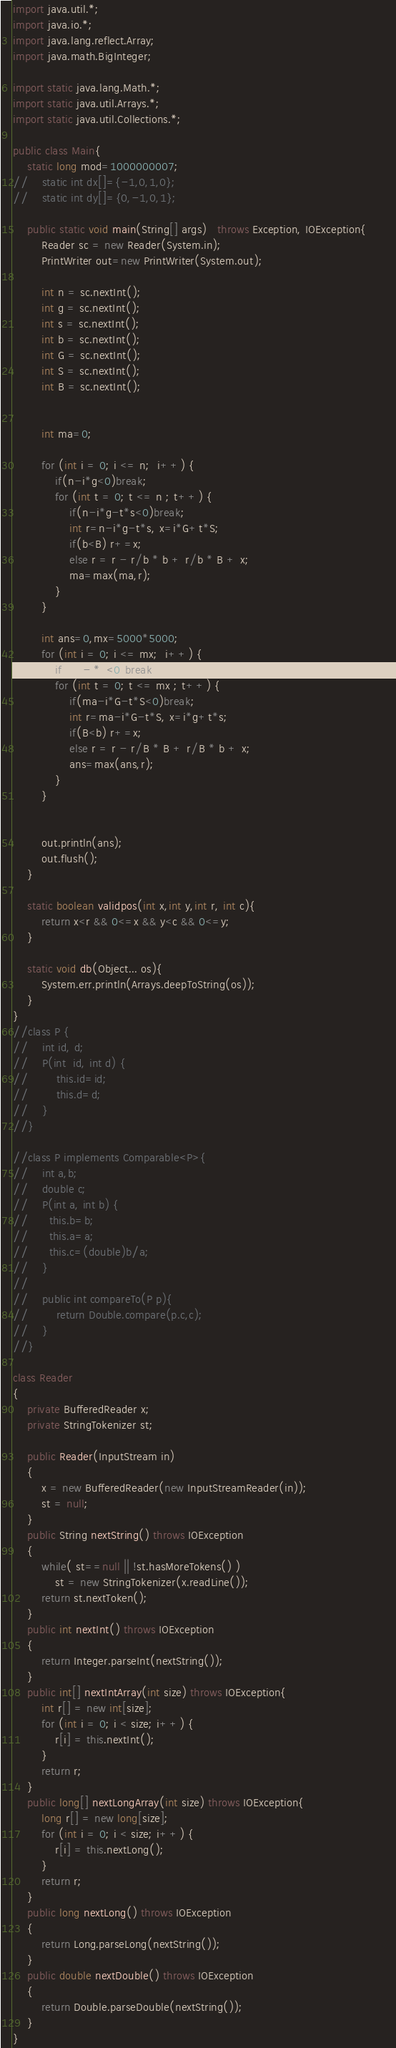<code> <loc_0><loc_0><loc_500><loc_500><_Java_>import java.util.*;
import java.io.*;
import java.lang.reflect.Array;
import java.math.BigInteger;

import static java.lang.Math.*;
import static java.util.Arrays.*;
import static java.util.Collections.*;
 
public class Main{
    static long mod=1000000007;
//    static int dx[]={-1,0,1,0};
//    static int dy[]={0,-1,0,1};

    public static void main(String[] args)   throws Exception, IOException{        
        Reader sc = new Reader(System.in);
        PrintWriter out=new PrintWriter(System.out);

        int n = sc.nextInt();
        int g = sc.nextInt();
        int s = sc.nextInt();
        int b = sc.nextInt();
        int G = sc.nextInt();
        int S = sc.nextInt();
        int B = sc.nextInt();

        
        int ma=0;
        
        for (int i = 0; i <= n;  i++) {
        	if(n-i*g<0)break;
			for (int t = 0; t <= n ; t++) {
	        	if(n-i*g-t*s<0)break;
				int r=n-i*g-t*s, x=i*G+t*S;
				if(b<B) r+=x;
				else r = r - r/b * b + r/b * B + x;
				ma=max(ma,r);
			}
		}
        
        int ans=0,mx=5000*5000;
        for (int i = 0; i <= mx;  i++) {
        	if(ma-i*G<0)break;
			for (int t = 0; t <= mx ; t++) {
	        	if(ma-i*G-t*S<0)break;
				int r=ma-i*G-t*S, x=i*g+t*s;
				if(B<b) r+=x;
				else r = r - r/B * B + r/B * b + x;
				ans=max(ans,r);
			}
		}


        out.println(ans);
        out.flush();
    }

    static boolean validpos(int x,int y,int r, int c){
        return x<r && 0<=x && y<c && 0<=y;
    }

    static void db(Object... os){
        System.err.println(Arrays.deepToString(os));
    }
}
//class P {
//    int id, d;
//    P(int  id, int d) {
//        this.id=id;
//        this.d=d;
//    }
//}

//class P implements Comparable<P>{
//    int a,b;
//    double c;
//    P(int a, int b) {
//    	this.b=b;
//    	this.a=a;
//    	this.c=(double)b/a;
//    }
//
//    public int compareTo(P p){
//        return Double.compare(p.c,c);
//    }
//}

class Reader
{ 
    private BufferedReader x;
    private StringTokenizer st;
    
    public Reader(InputStream in)
    {
        x = new BufferedReader(new InputStreamReader(in));
        st = null;
    }
    public String nextString() throws IOException
    {
        while( st==null || !st.hasMoreTokens() )
            st = new StringTokenizer(x.readLine());
        return st.nextToken();
    }
    public int nextInt() throws IOException
    {
        return Integer.parseInt(nextString());
    }
    public int[] nextIntArray(int size) throws IOException{
        int r[] = new int[size];
        for (int i = 0; i < size; i++) {
            r[i] = this.nextInt(); 
        }
        return r;
    }
    public long[] nextLongArray(int size) throws IOException{
        long r[] = new long[size];
        for (int i = 0; i < size; i++) {
            r[i] = this.nextLong(); 
        }
        return r;
    }
    public long nextLong() throws IOException
    {
        return Long.parseLong(nextString());
    }
    public double nextDouble() throws IOException
    {
        return Double.parseDouble(nextString());
    }
}
</code> 